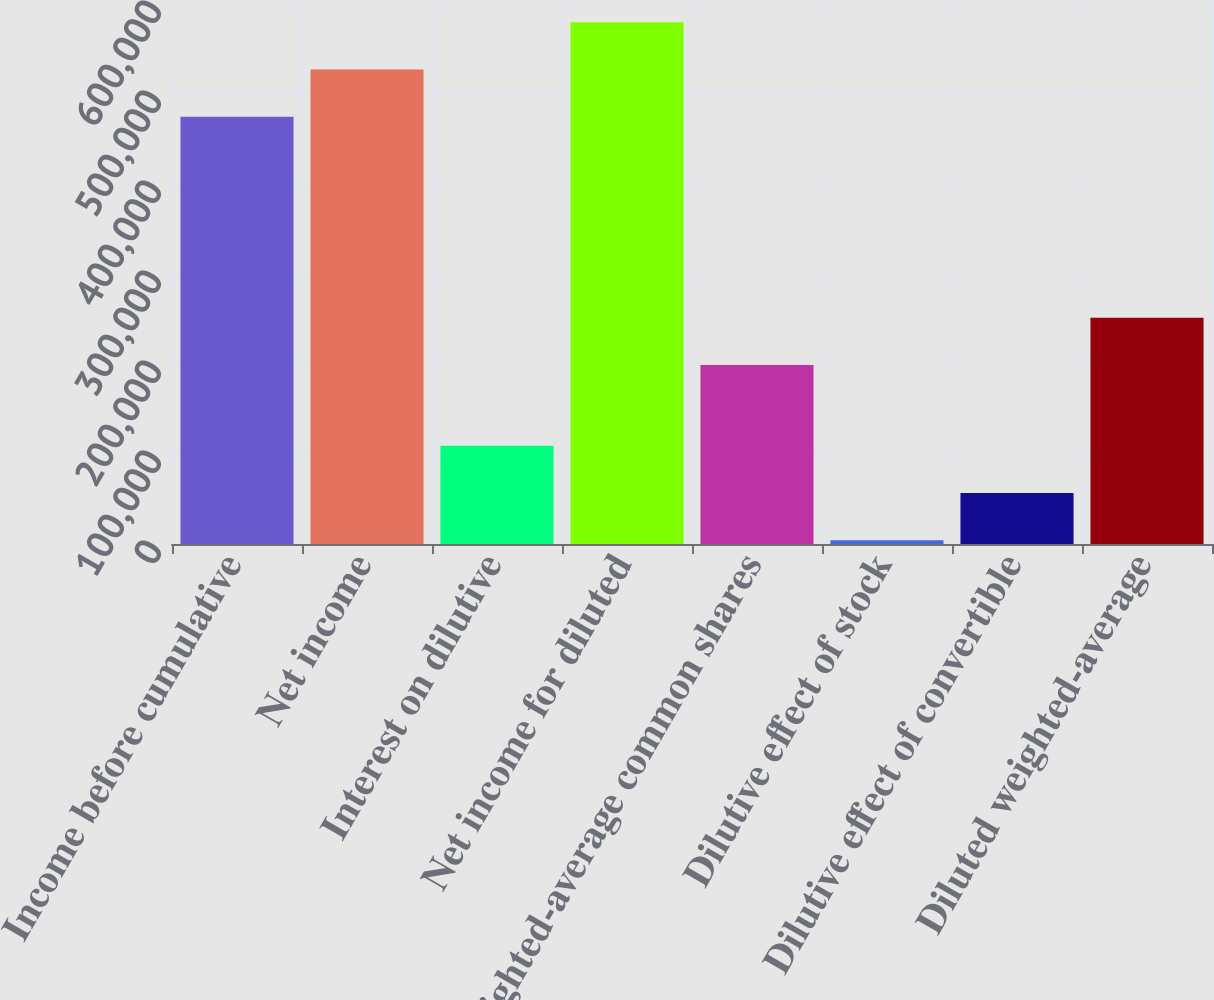<chart> <loc_0><loc_0><loc_500><loc_500><bar_chart><fcel>Income before cumulative<fcel>Net income<fcel>Interest on dilutive<fcel>Net income for diluted<fcel>Weighted-average common shares<fcel>Dilutive effect of stock<fcel>Dilutive effect of convertible<fcel>Diluted weighted-average<nl><fcel>474691<fcel>527197<fcel>109173<fcel>579703<fcel>198946<fcel>4161<fcel>56667<fcel>251452<nl></chart> 